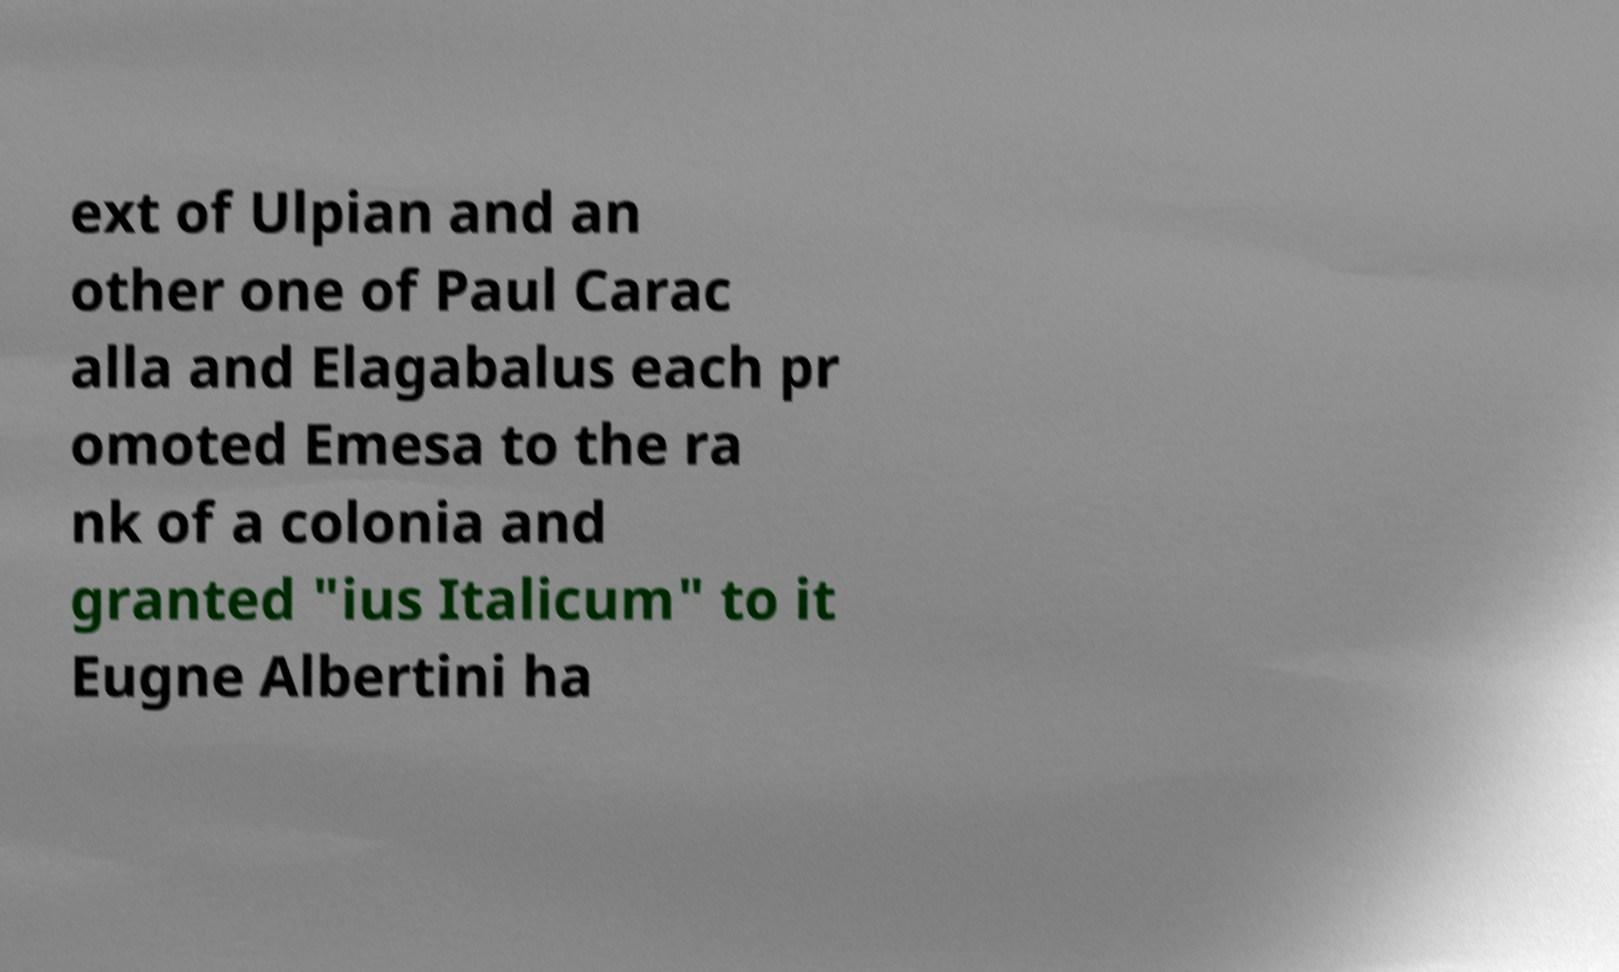What messages or text are displayed in this image? I need them in a readable, typed format. ext of Ulpian and an other one of Paul Carac alla and Elagabalus each pr omoted Emesa to the ra nk of a colonia and granted "ius Italicum" to it Eugne Albertini ha 